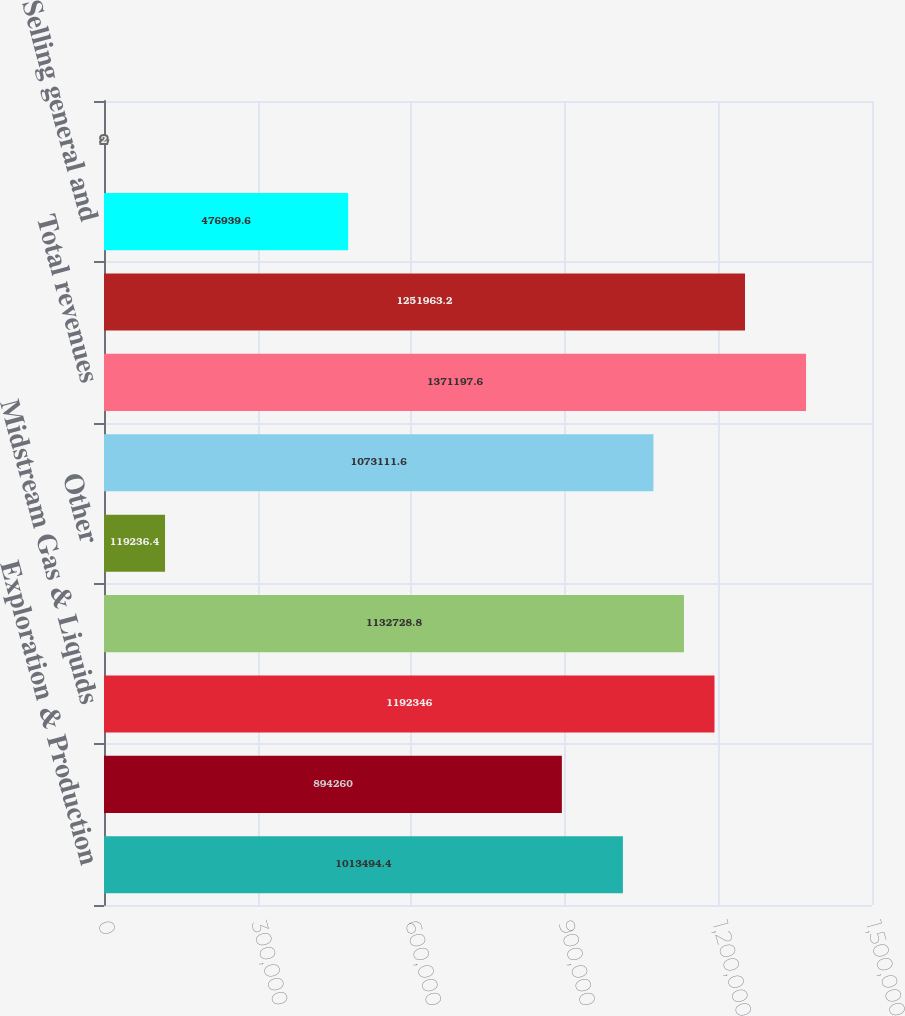Convert chart to OTSL. <chart><loc_0><loc_0><loc_500><loc_500><bar_chart><fcel>Exploration & Production<fcel>Gas Pipeline<fcel>Midstream Gas & Liquids<fcel>Gas Marketing Services<fcel>Other<fcel>Intercompany eliminations<fcel>Total revenues<fcel>Costs and operating expenses<fcel>Selling general and<fcel>Other (income) expense - net<nl><fcel>1.01349e+06<fcel>894260<fcel>1.19235e+06<fcel>1.13273e+06<fcel>119236<fcel>1.07311e+06<fcel>1.3712e+06<fcel>1.25196e+06<fcel>476940<fcel>2<nl></chart> 